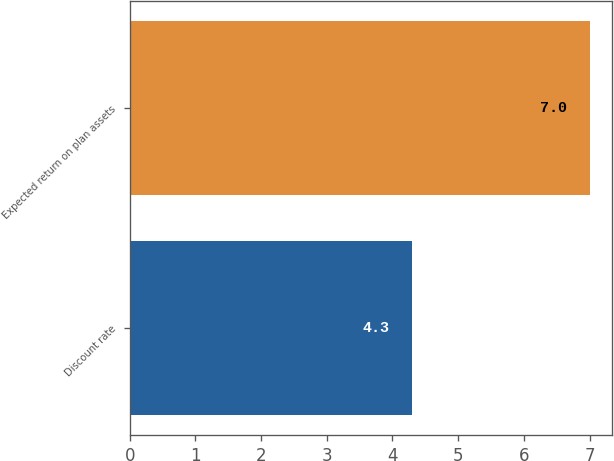<chart> <loc_0><loc_0><loc_500><loc_500><bar_chart><fcel>Discount rate<fcel>Expected return on plan assets<nl><fcel>4.3<fcel>7<nl></chart> 